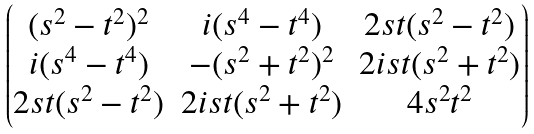<formula> <loc_0><loc_0><loc_500><loc_500>\begin{pmatrix} ( s ^ { 2 } - t ^ { 2 } ) ^ { 2 } & i ( s ^ { 4 } - t ^ { 4 } ) & 2 s t ( s ^ { 2 } - t ^ { 2 } ) \\ i ( s ^ { 4 } - t ^ { 4 } ) & - ( s ^ { 2 } + t ^ { 2 } ) ^ { 2 } & 2 i s t ( s ^ { 2 } + t ^ { 2 } ) \\ 2 s t ( s ^ { 2 } - t ^ { 2 } ) & 2 i s t ( s ^ { 2 } + t ^ { 2 } ) & 4 s ^ { 2 } t ^ { 2 } \end{pmatrix}</formula> 